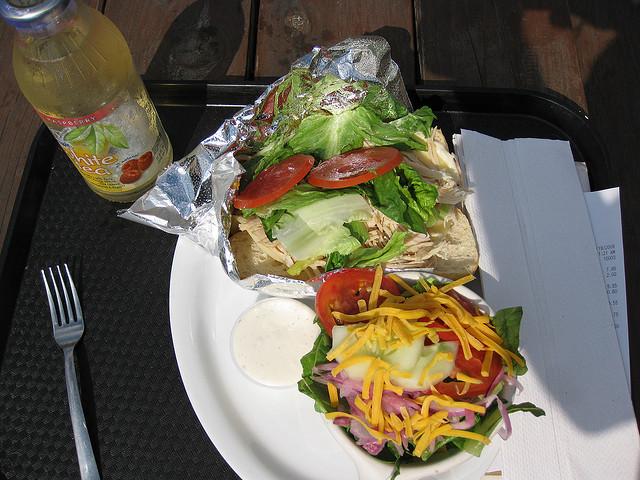What type of beverage?
Give a very brief answer. Tea. How many people is this meal for?
Write a very short answer. 1. What is the eating utensil called?
Keep it brief. Fork. 